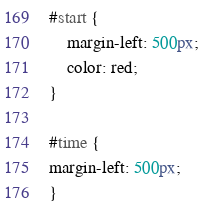Convert code to text. <code><loc_0><loc_0><loc_500><loc_500><_CSS_>#start {
	margin-left: 500px;
	color: red;
}

#time {
margin-left: 500px;
}</code> 